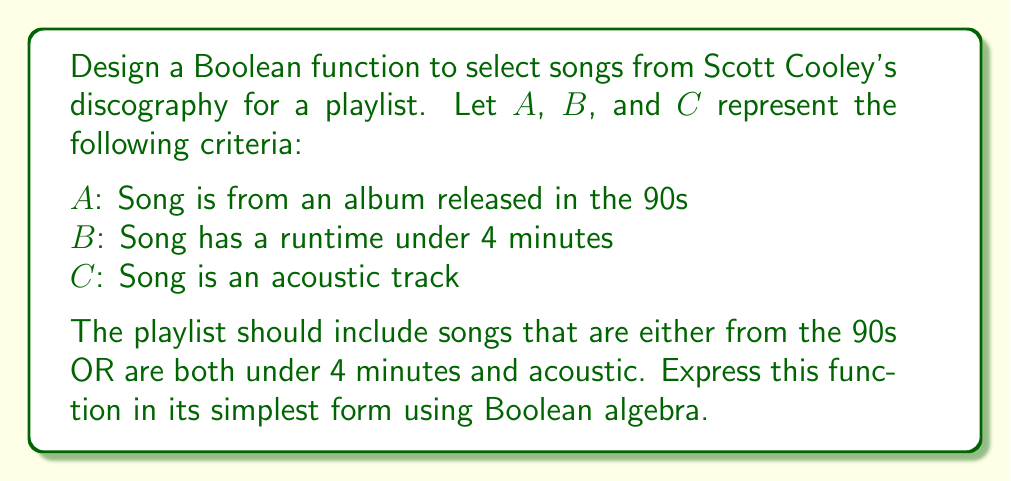Teach me how to tackle this problem. Let's approach this step-by-step:

1) First, we need to translate the playlist requirements into a Boolean expression:
   $F = A + (B \cdot C)$

2) This expression is already in disjunctive normal form (DNF), but we should check if it can be simplified further.

3) We can use the distributive law to expand this expression:
   $F = A + (B \cdot C)$
   $F = (A + B) \cdot (A + C)$

4) Now, let's apply the absorption law:
   $A + (A \cdot B) = A$
   $A + (A \cdot C) = A$

5) Therefore:
   $F = (A + B) \cdot (A + C)$
   $F = A + (B \cdot C)$

6) We've arrived back at our original expression, which means it was already in its simplest form.

This Boolean function will select songs that are either from the 90s (A), or are both under 4 minutes (B) and acoustic (C).
Answer: $A + (B \cdot C)$ 